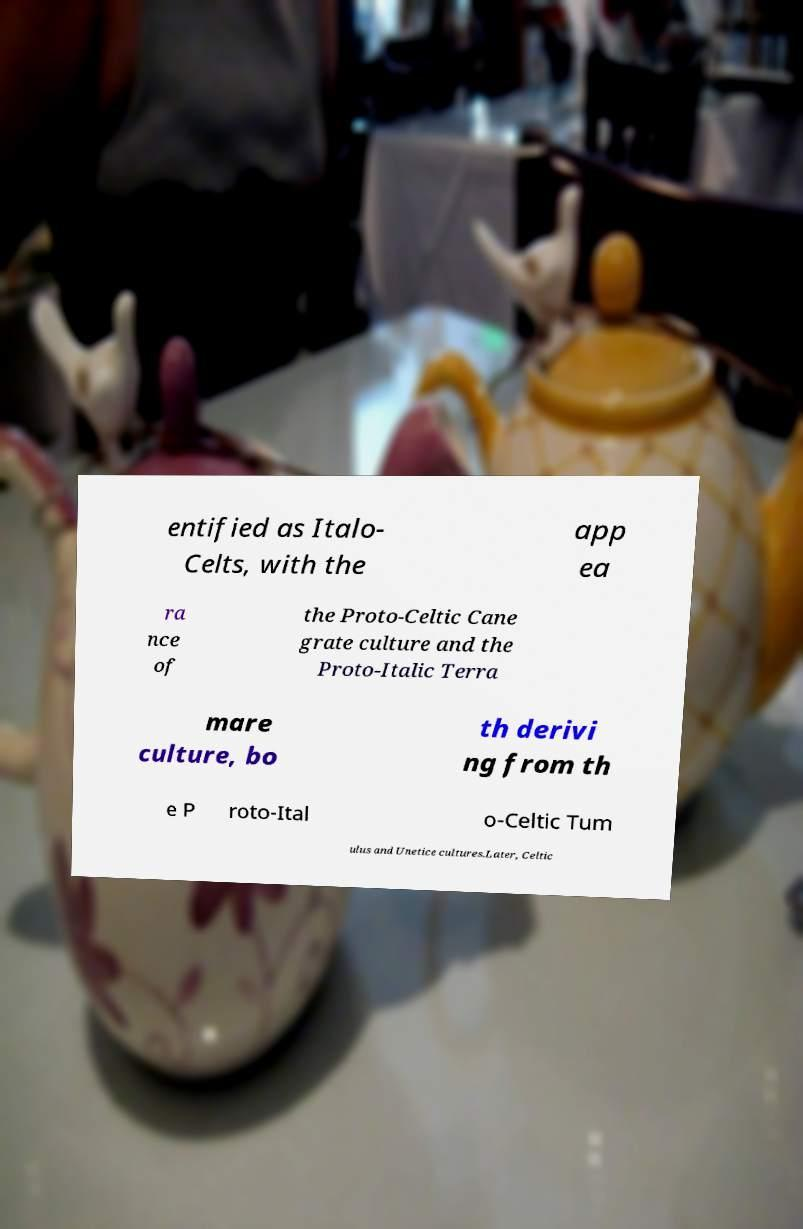Can you accurately transcribe the text from the provided image for me? entified as Italo- Celts, with the app ea ra nce of the Proto-Celtic Cane grate culture and the Proto-Italic Terra mare culture, bo th derivi ng from th e P roto-Ital o-Celtic Tum ulus and Unetice cultures.Later, Celtic 